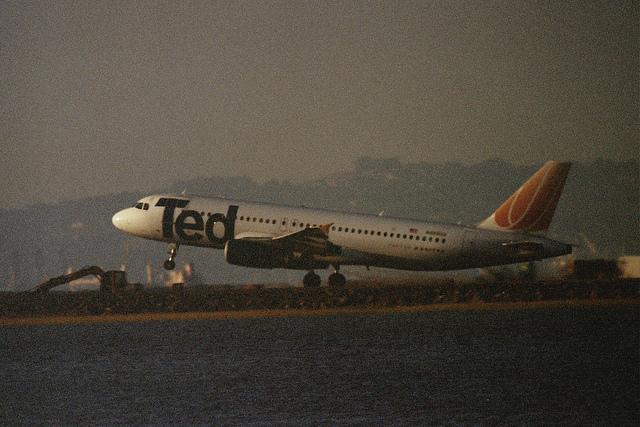How many wheels does the plane have?
Give a very brief answer. 3. What letters are on the plane?
Be succinct. Ted. Is the airplane flying?
Quick response, please. No. Is the plane taking off or landing?
Short answer required. Taking off. On the tail of the plane, what are the three letters written?
Quick response, please. Ted. How many letter D are on the plane?
Give a very brief answer. 1. What is the name on the airplane?
Concise answer only. Ted. Is the plane taking off in the daytime or night time?
Be succinct. Night time. Is it cloudy?
Keep it brief. Yes. What 3 letter word is on the wing of the plane?
Keep it brief. Ted. Is the plane on the ground?
Concise answer only. No. What airline is that?
Answer briefly. Ted. 